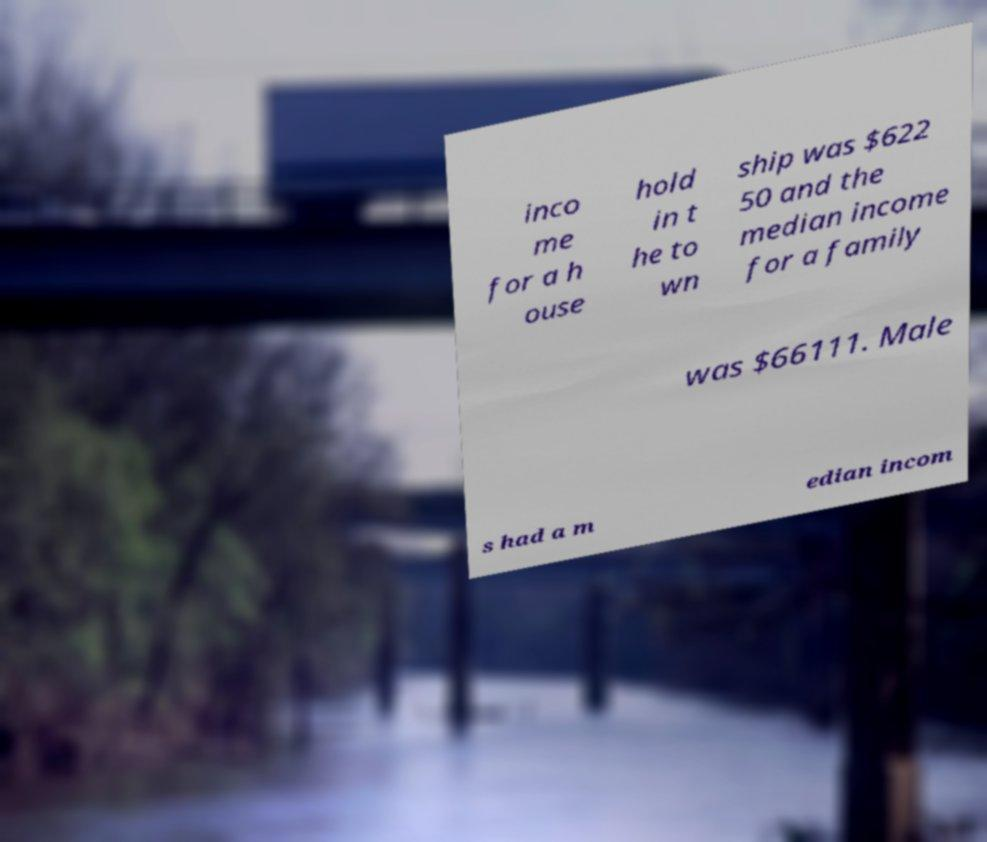Please read and relay the text visible in this image. What does it say? inco me for a h ouse hold in t he to wn ship was $622 50 and the median income for a family was $66111. Male s had a m edian incom 